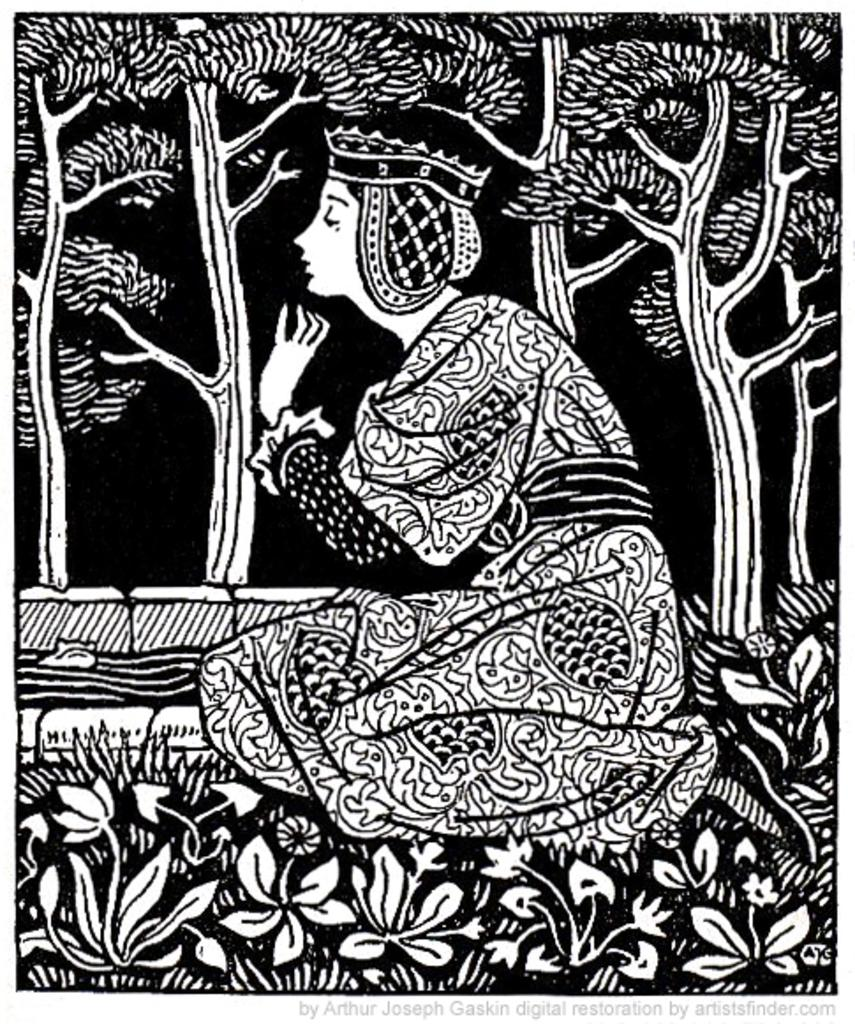What is the main subject of the sketch in the image? The main subject of the sketch is a woman sitting. What can be seen at the bottom of the sketch? There are plants at the bottom of the sketch. What type of vegetation is visible in the background of the sketch? There are trees visible at the back side of the sketch. How many circles can be seen in the sketch? There are no circles present in the sketch; it is a sketch of a woman sitting with plants and trees in the background. 